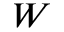<formula> <loc_0><loc_0><loc_500><loc_500>W</formula> 